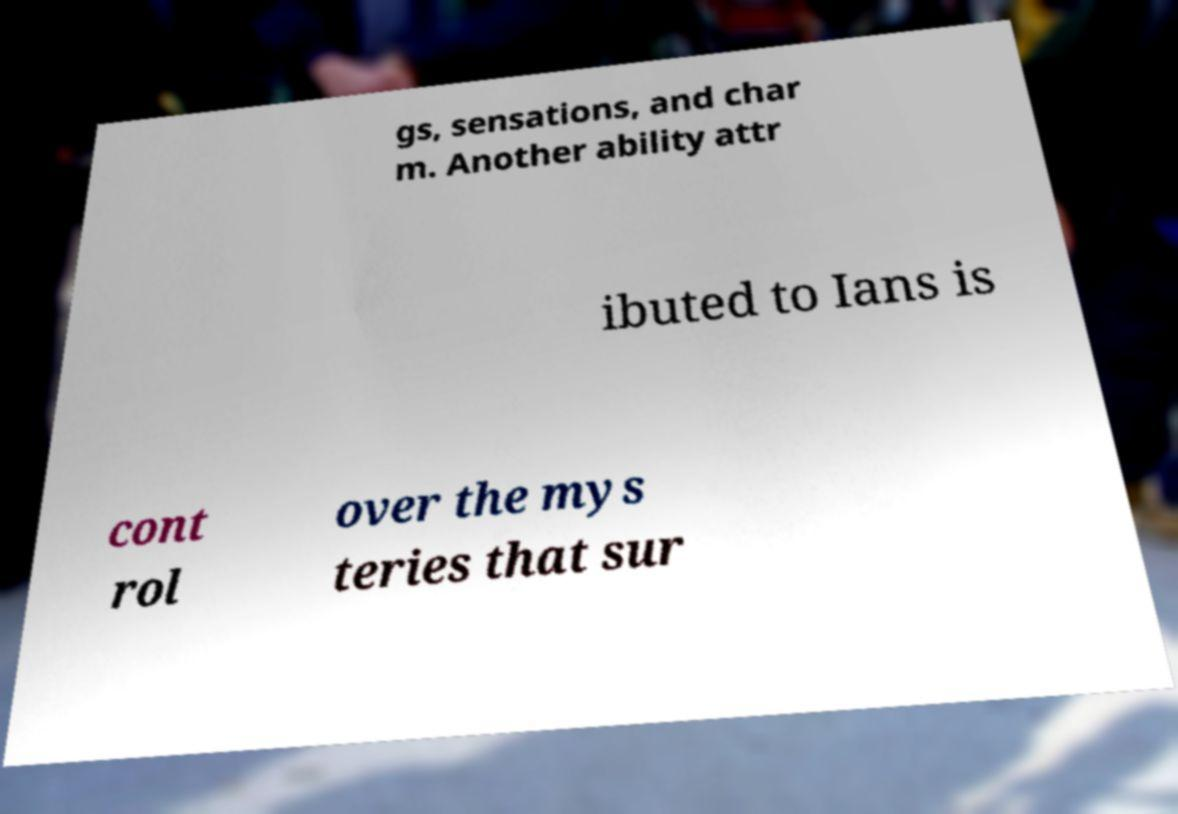Can you accurately transcribe the text from the provided image for me? gs, sensations, and char m. Another ability attr ibuted to Ians is cont rol over the mys teries that sur 